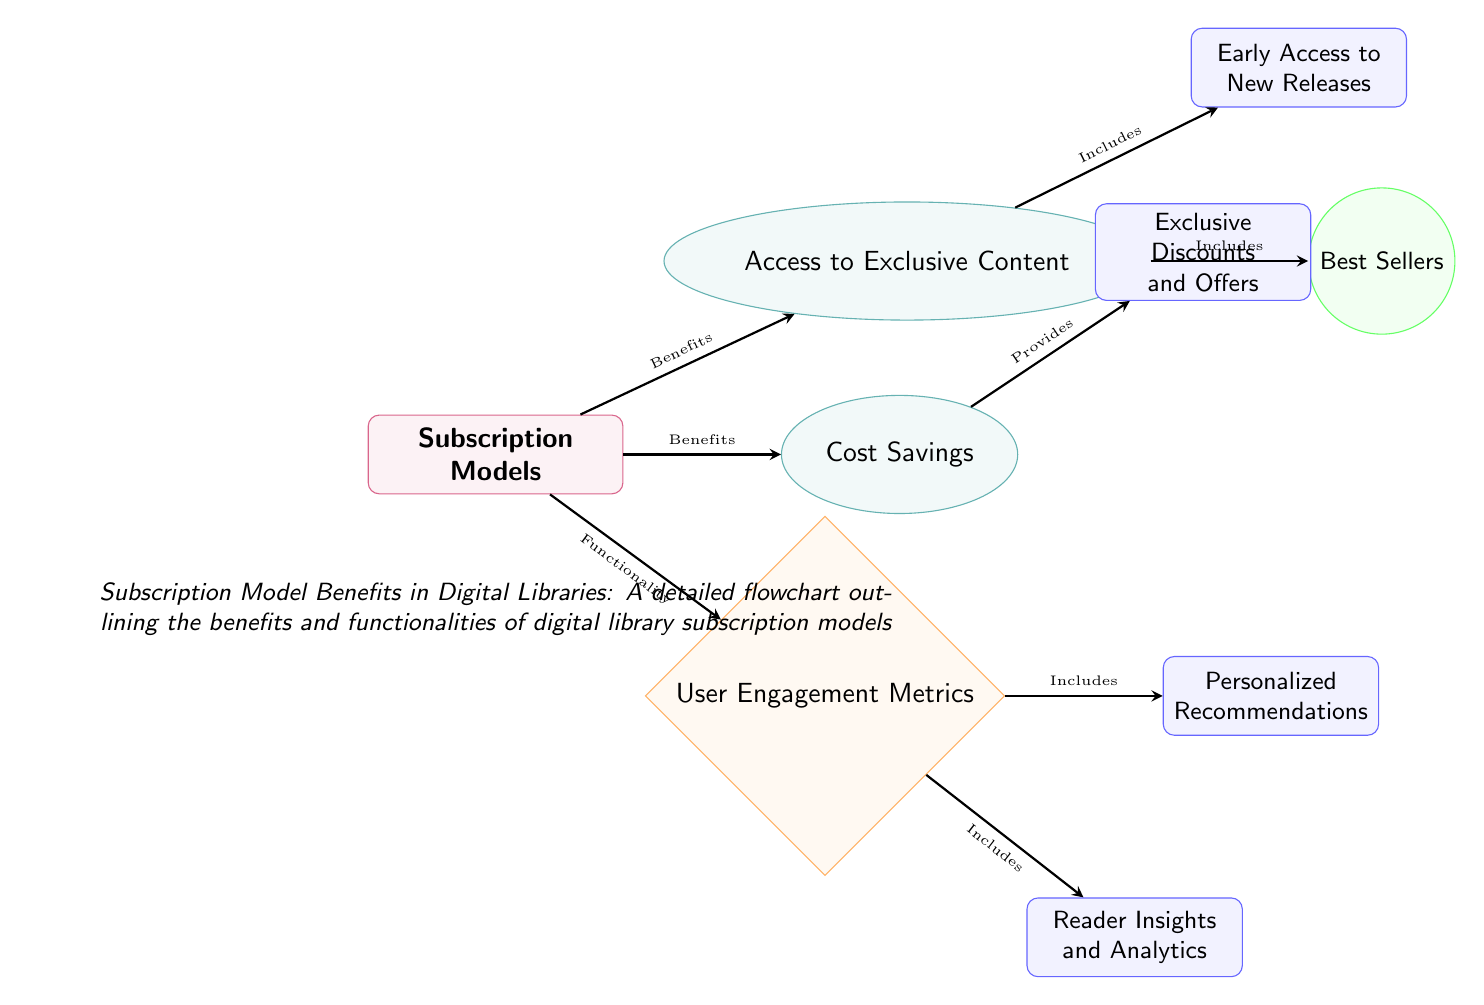What is the main category depicted in the diagram? The diagram's main category is labeled 'Subscription Models', which is the central node from which all other benefits and functionalities branch out.
Answer: Subscription Models How many benefits are listed in the diagram? There are two benefits indicated in the diagram: 'Access to Exclusive Content' and 'Cost Savings', which are directly connected to the main category node.
Answer: 2 Which benefit includes 'Early Access to New Releases'? This feature is part of the 'Access to Exclusive Content' benefit, as shown in the diagram where 'Early Access to New Releases' is connected to 'Access to Exclusive Content'.
Answer: Access to Exclusive Content What functionality is associated with user engagement metrics? The functionality related to user engagement is labeled 'User Engagement Metrics', which is directly linked to the Subscription Models category node.
Answer: User Engagement Metrics What are the two features linked to 'User Engagement Metrics'? The diagram specifies 'Personalized Recommendations' and 'Reader Insights and Analytics' as the two features connected to the 'User Engagement Metrics' functionality.
Answer: Personalized Recommendations, Reader Insights and Analytics Which benefit provides 'Exclusive Discounts and Offers'? The benefit that provides 'Exclusive Discounts and Offers' is 'Cost Savings', which is indicated by the connection leading from the 'Cost Savings' benefit to the 'Exclusive Discounts and Offers' feature.
Answer: Cost Savings How many features are linked directly to the 'Access to Exclusive Content' benefit? There are two features associated with 'Access to Exclusive Content': 'Early Access to New Releases' and 'Best Sellers', as represented in the diagram.
Answer: 2 What type of node is used to represent 'Cost Savings'? 'Cost Savings' is represented by an ellipse in the diagram, which is the designated style for benefits nodes according to the provided styles.
Answer: Ellipse What are the user engagement functionalities listed in the diagram? The functionalities related to user engagement are 'Personalized Recommendations' and 'Reader Insights and Analytics', both of which fall under the 'User Engagement Metrics' category in the flowchart.
Answer: Personalized Recommendations, Reader Insights and Analytics 